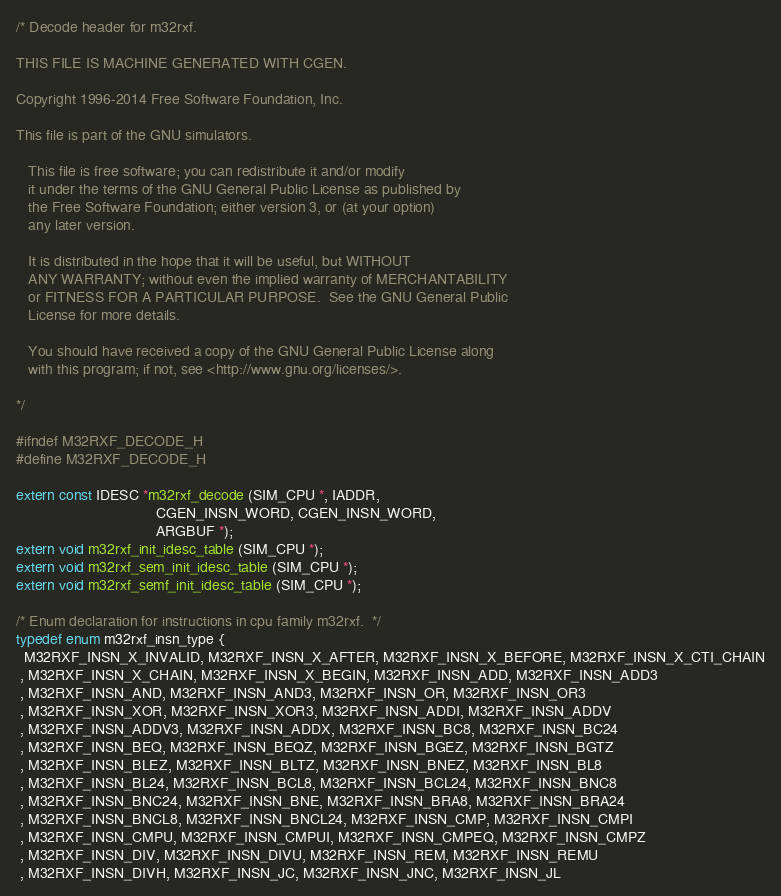Convert code to text. <code><loc_0><loc_0><loc_500><loc_500><_C_>/* Decode header for m32rxf.

THIS FILE IS MACHINE GENERATED WITH CGEN.

Copyright 1996-2014 Free Software Foundation, Inc.

This file is part of the GNU simulators.

   This file is free software; you can redistribute it and/or modify
   it under the terms of the GNU General Public License as published by
   the Free Software Foundation; either version 3, or (at your option)
   any later version.

   It is distributed in the hope that it will be useful, but WITHOUT
   ANY WARRANTY; without even the implied warranty of MERCHANTABILITY
   or FITNESS FOR A PARTICULAR PURPOSE.  See the GNU General Public
   License for more details.

   You should have received a copy of the GNU General Public License along
   with this program; if not, see <http://www.gnu.org/licenses/>.

*/

#ifndef M32RXF_DECODE_H
#define M32RXF_DECODE_H

extern const IDESC *m32rxf_decode (SIM_CPU *, IADDR,
                                  CGEN_INSN_WORD, CGEN_INSN_WORD,
                                  ARGBUF *);
extern void m32rxf_init_idesc_table (SIM_CPU *);
extern void m32rxf_sem_init_idesc_table (SIM_CPU *);
extern void m32rxf_semf_init_idesc_table (SIM_CPU *);

/* Enum declaration for instructions in cpu family m32rxf.  */
typedef enum m32rxf_insn_type {
  M32RXF_INSN_X_INVALID, M32RXF_INSN_X_AFTER, M32RXF_INSN_X_BEFORE, M32RXF_INSN_X_CTI_CHAIN
 , M32RXF_INSN_X_CHAIN, M32RXF_INSN_X_BEGIN, M32RXF_INSN_ADD, M32RXF_INSN_ADD3
 , M32RXF_INSN_AND, M32RXF_INSN_AND3, M32RXF_INSN_OR, M32RXF_INSN_OR3
 , M32RXF_INSN_XOR, M32RXF_INSN_XOR3, M32RXF_INSN_ADDI, M32RXF_INSN_ADDV
 , M32RXF_INSN_ADDV3, M32RXF_INSN_ADDX, M32RXF_INSN_BC8, M32RXF_INSN_BC24
 , M32RXF_INSN_BEQ, M32RXF_INSN_BEQZ, M32RXF_INSN_BGEZ, M32RXF_INSN_BGTZ
 , M32RXF_INSN_BLEZ, M32RXF_INSN_BLTZ, M32RXF_INSN_BNEZ, M32RXF_INSN_BL8
 , M32RXF_INSN_BL24, M32RXF_INSN_BCL8, M32RXF_INSN_BCL24, M32RXF_INSN_BNC8
 , M32RXF_INSN_BNC24, M32RXF_INSN_BNE, M32RXF_INSN_BRA8, M32RXF_INSN_BRA24
 , M32RXF_INSN_BNCL8, M32RXF_INSN_BNCL24, M32RXF_INSN_CMP, M32RXF_INSN_CMPI
 , M32RXF_INSN_CMPU, M32RXF_INSN_CMPUI, M32RXF_INSN_CMPEQ, M32RXF_INSN_CMPZ
 , M32RXF_INSN_DIV, M32RXF_INSN_DIVU, M32RXF_INSN_REM, M32RXF_INSN_REMU
 , M32RXF_INSN_DIVH, M32RXF_INSN_JC, M32RXF_INSN_JNC, M32RXF_INSN_JL</code> 